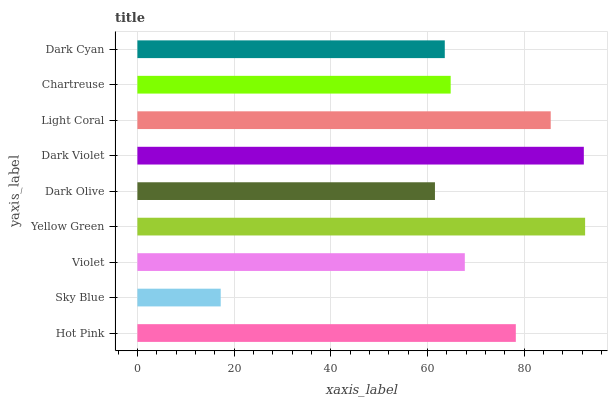Is Sky Blue the minimum?
Answer yes or no. Yes. Is Yellow Green the maximum?
Answer yes or no. Yes. Is Violet the minimum?
Answer yes or no. No. Is Violet the maximum?
Answer yes or no. No. Is Violet greater than Sky Blue?
Answer yes or no. Yes. Is Sky Blue less than Violet?
Answer yes or no. Yes. Is Sky Blue greater than Violet?
Answer yes or no. No. Is Violet less than Sky Blue?
Answer yes or no. No. Is Violet the high median?
Answer yes or no. Yes. Is Violet the low median?
Answer yes or no. Yes. Is Yellow Green the high median?
Answer yes or no. No. Is Dark Violet the low median?
Answer yes or no. No. 